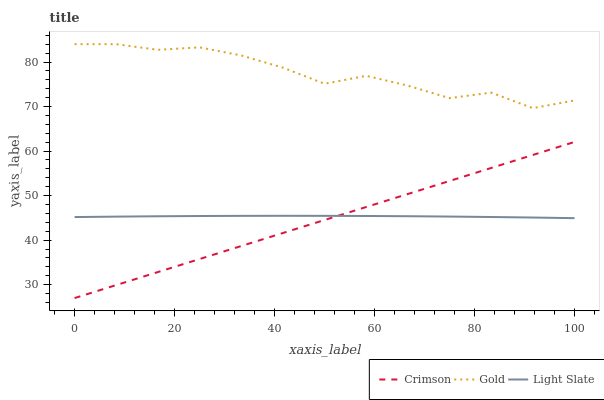Does Crimson have the minimum area under the curve?
Answer yes or no. Yes. Does Gold have the maximum area under the curve?
Answer yes or no. Yes. Does Light Slate have the minimum area under the curve?
Answer yes or no. No. Does Light Slate have the maximum area under the curve?
Answer yes or no. No. Is Crimson the smoothest?
Answer yes or no. Yes. Is Gold the roughest?
Answer yes or no. Yes. Is Light Slate the smoothest?
Answer yes or no. No. Is Light Slate the roughest?
Answer yes or no. No. Does Crimson have the lowest value?
Answer yes or no. Yes. Does Light Slate have the lowest value?
Answer yes or no. No. Does Gold have the highest value?
Answer yes or no. Yes. Does Light Slate have the highest value?
Answer yes or no. No. Is Crimson less than Gold?
Answer yes or no. Yes. Is Gold greater than Crimson?
Answer yes or no. Yes. Does Light Slate intersect Crimson?
Answer yes or no. Yes. Is Light Slate less than Crimson?
Answer yes or no. No. Is Light Slate greater than Crimson?
Answer yes or no. No. Does Crimson intersect Gold?
Answer yes or no. No. 